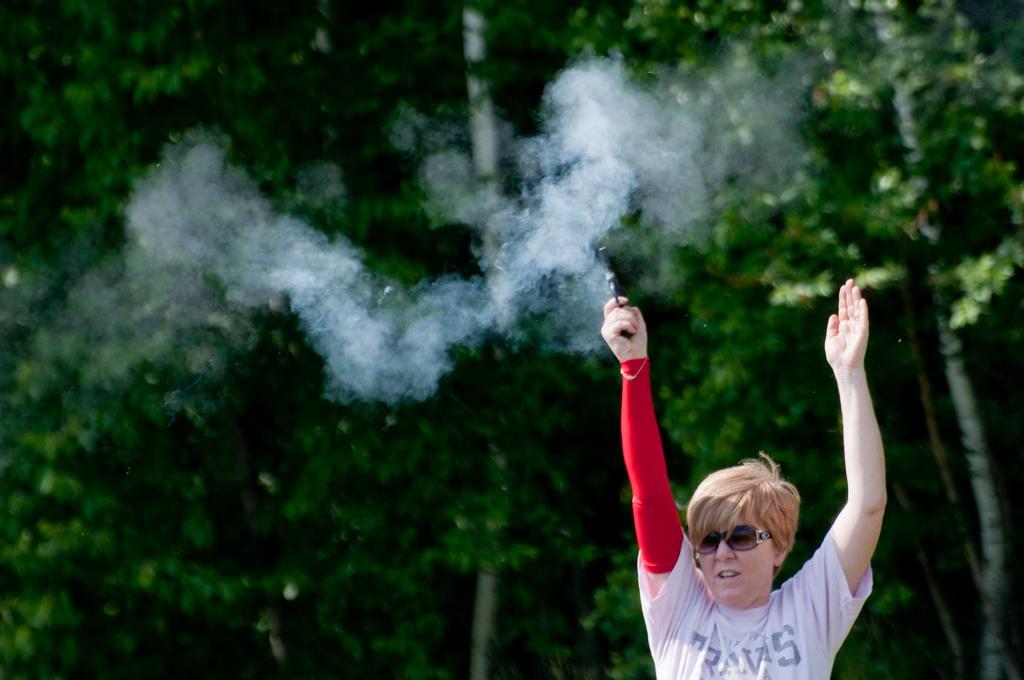In one or two sentences, can you explain what this image depicts? In this image there is one person is standing on the right side of this image is holding a gun. There are some trees in the background. 